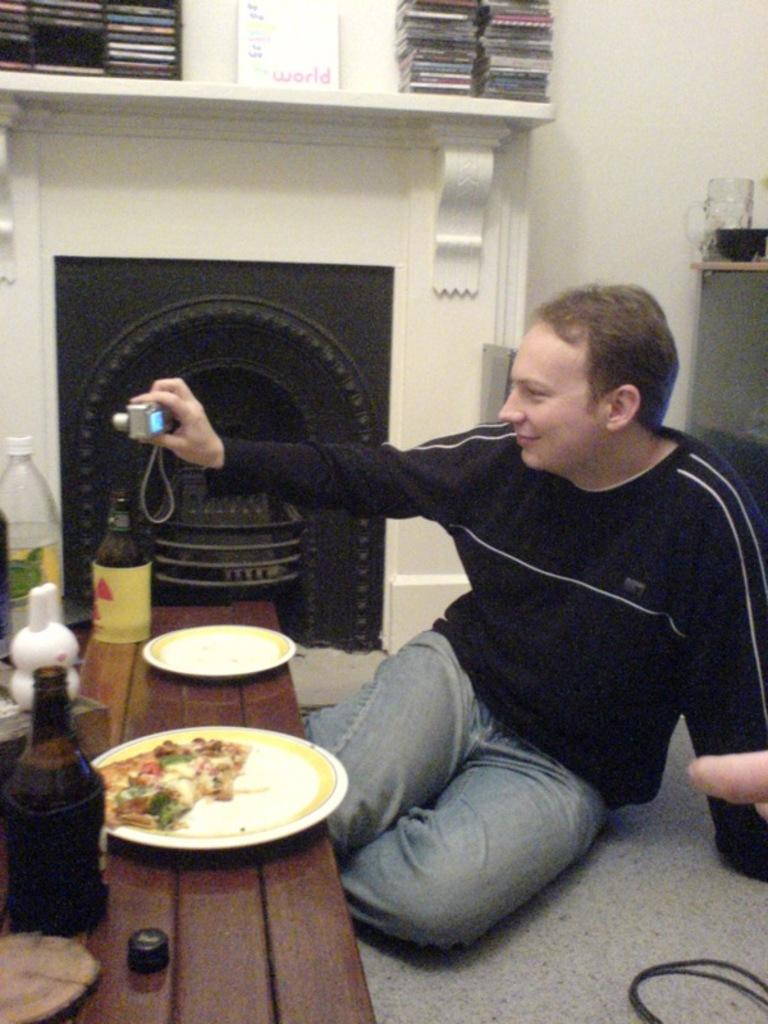<image>
Create a compact narrative representing the image presented. A man sits on the floor and takes a picture in front of a fireplace that has a white sign on the mantle that says world. 